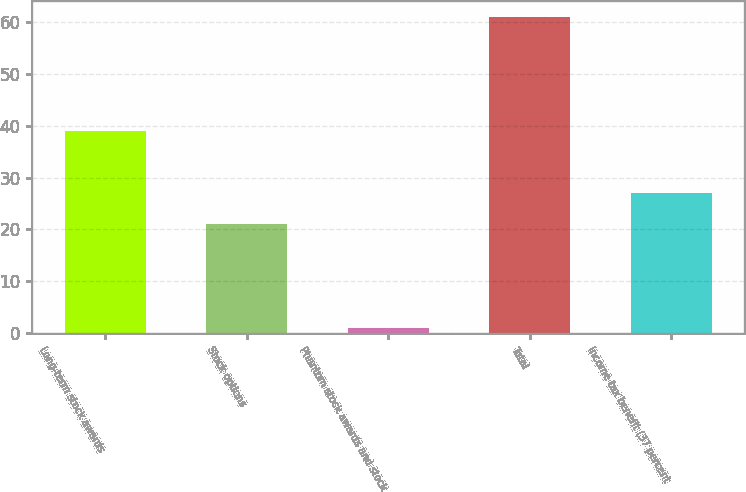Convert chart. <chart><loc_0><loc_0><loc_500><loc_500><bar_chart><fcel>Long-term stock awards<fcel>Stock options<fcel>Phantom stock awards and stock<fcel>Total<fcel>Income tax benefit (37 percent<nl><fcel>39<fcel>21<fcel>1<fcel>61<fcel>27<nl></chart> 